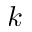<formula> <loc_0><loc_0><loc_500><loc_500>k</formula> 